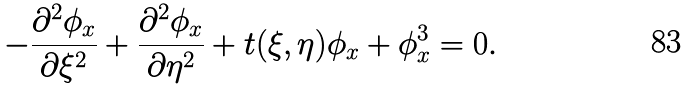Convert formula to latex. <formula><loc_0><loc_0><loc_500><loc_500>- \frac { \partial ^ { 2 } \phi _ { x } } { \partial \xi ^ { 2 } } + \frac { \partial ^ { 2 } \phi _ { x } } { \partial \eta ^ { 2 } } + t ( \xi , \eta ) \phi _ { x } + \phi _ { x } ^ { 3 } = 0 .</formula> 